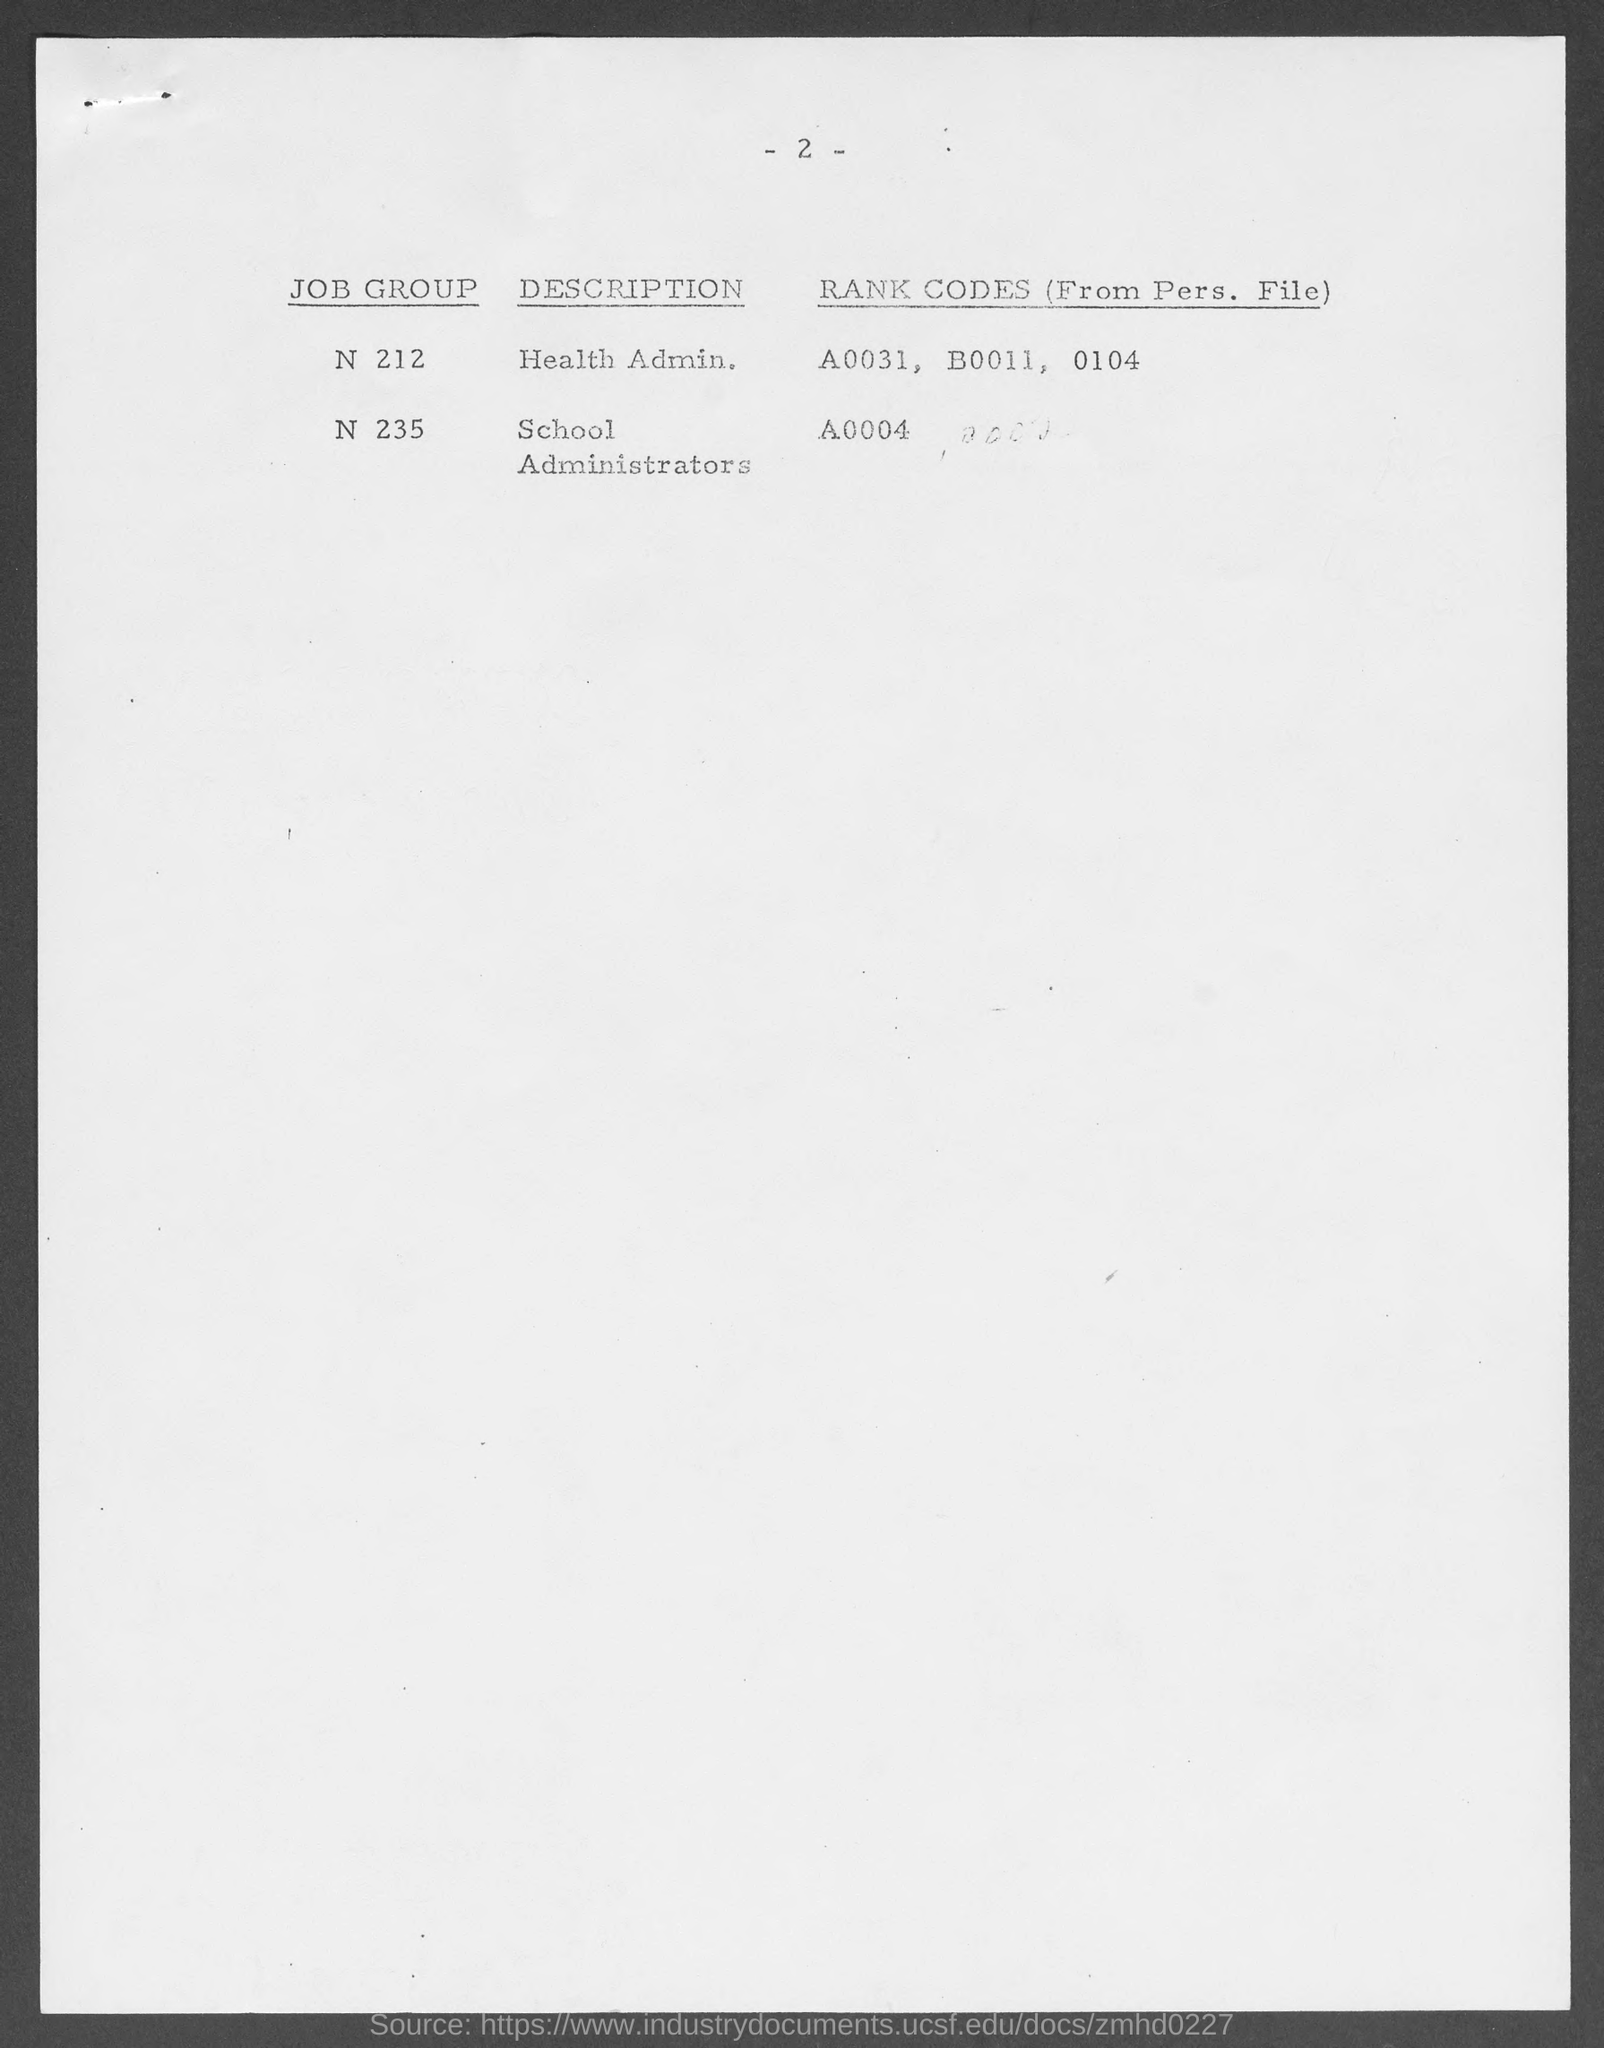Draw attention to some important aspects in this diagram. The rank code for job group N235 is A0004. The rank codes for job group N212 are A0031, B0011, and 0104. The job group 'N 235' is described as comprising School Administrators. For job group 'N 212,' the description is related to health administration. 